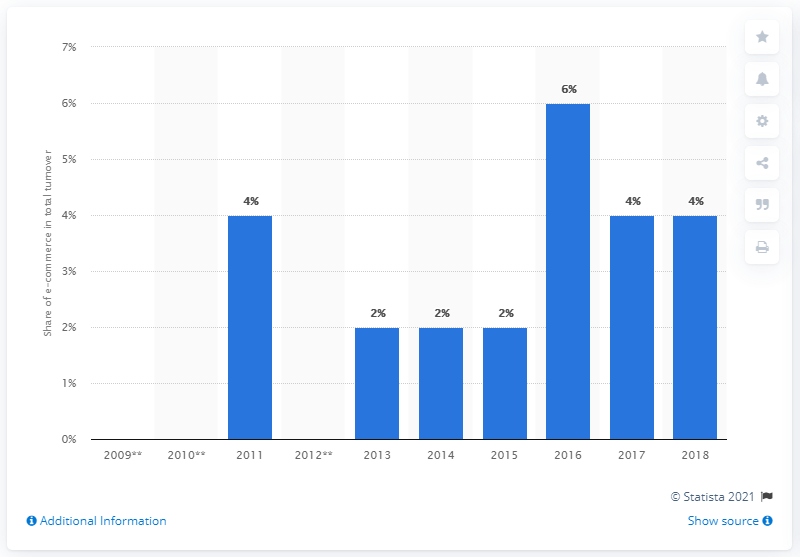Outline some significant characteristics in this image. According to data from 2018, e-commerce represented approximately 4% of the total turnover of enterprises in Greece. In 2016, e-commerce accounted for approximately 6% of the total turnover of Greek enterprises. 